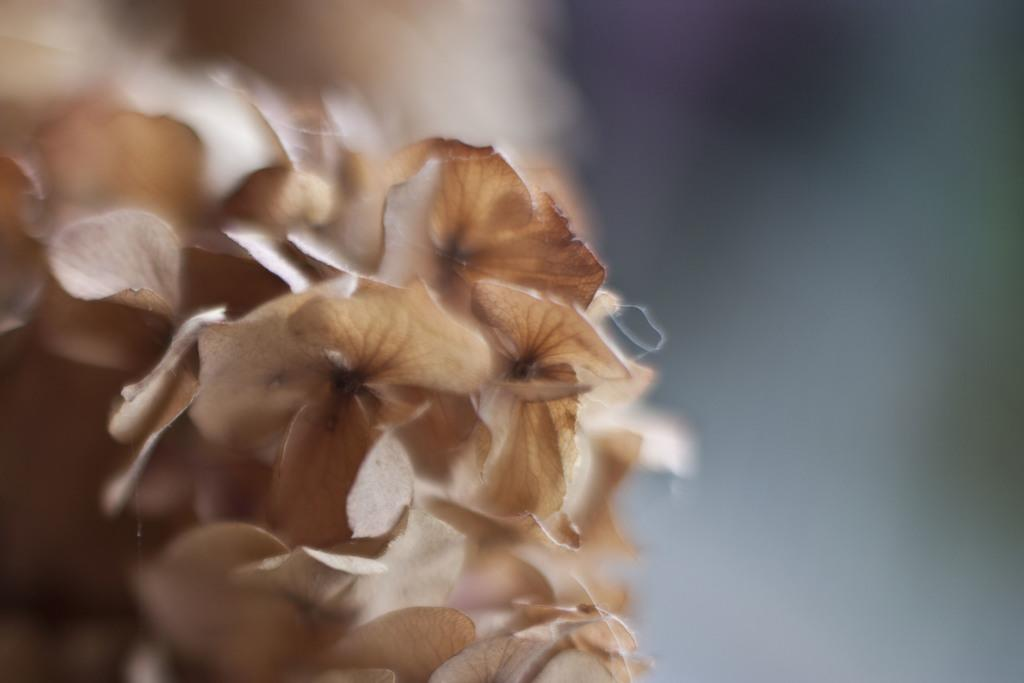What type of living organisms can be seen in the image? Plants can be seen in the image. Can you describe the background of the image? The background of the image is blurred. What degree of attention is required to notice the brush in the image? There is no brush present in the image, so it is not possible to determine the degree of attention required to notice it. 